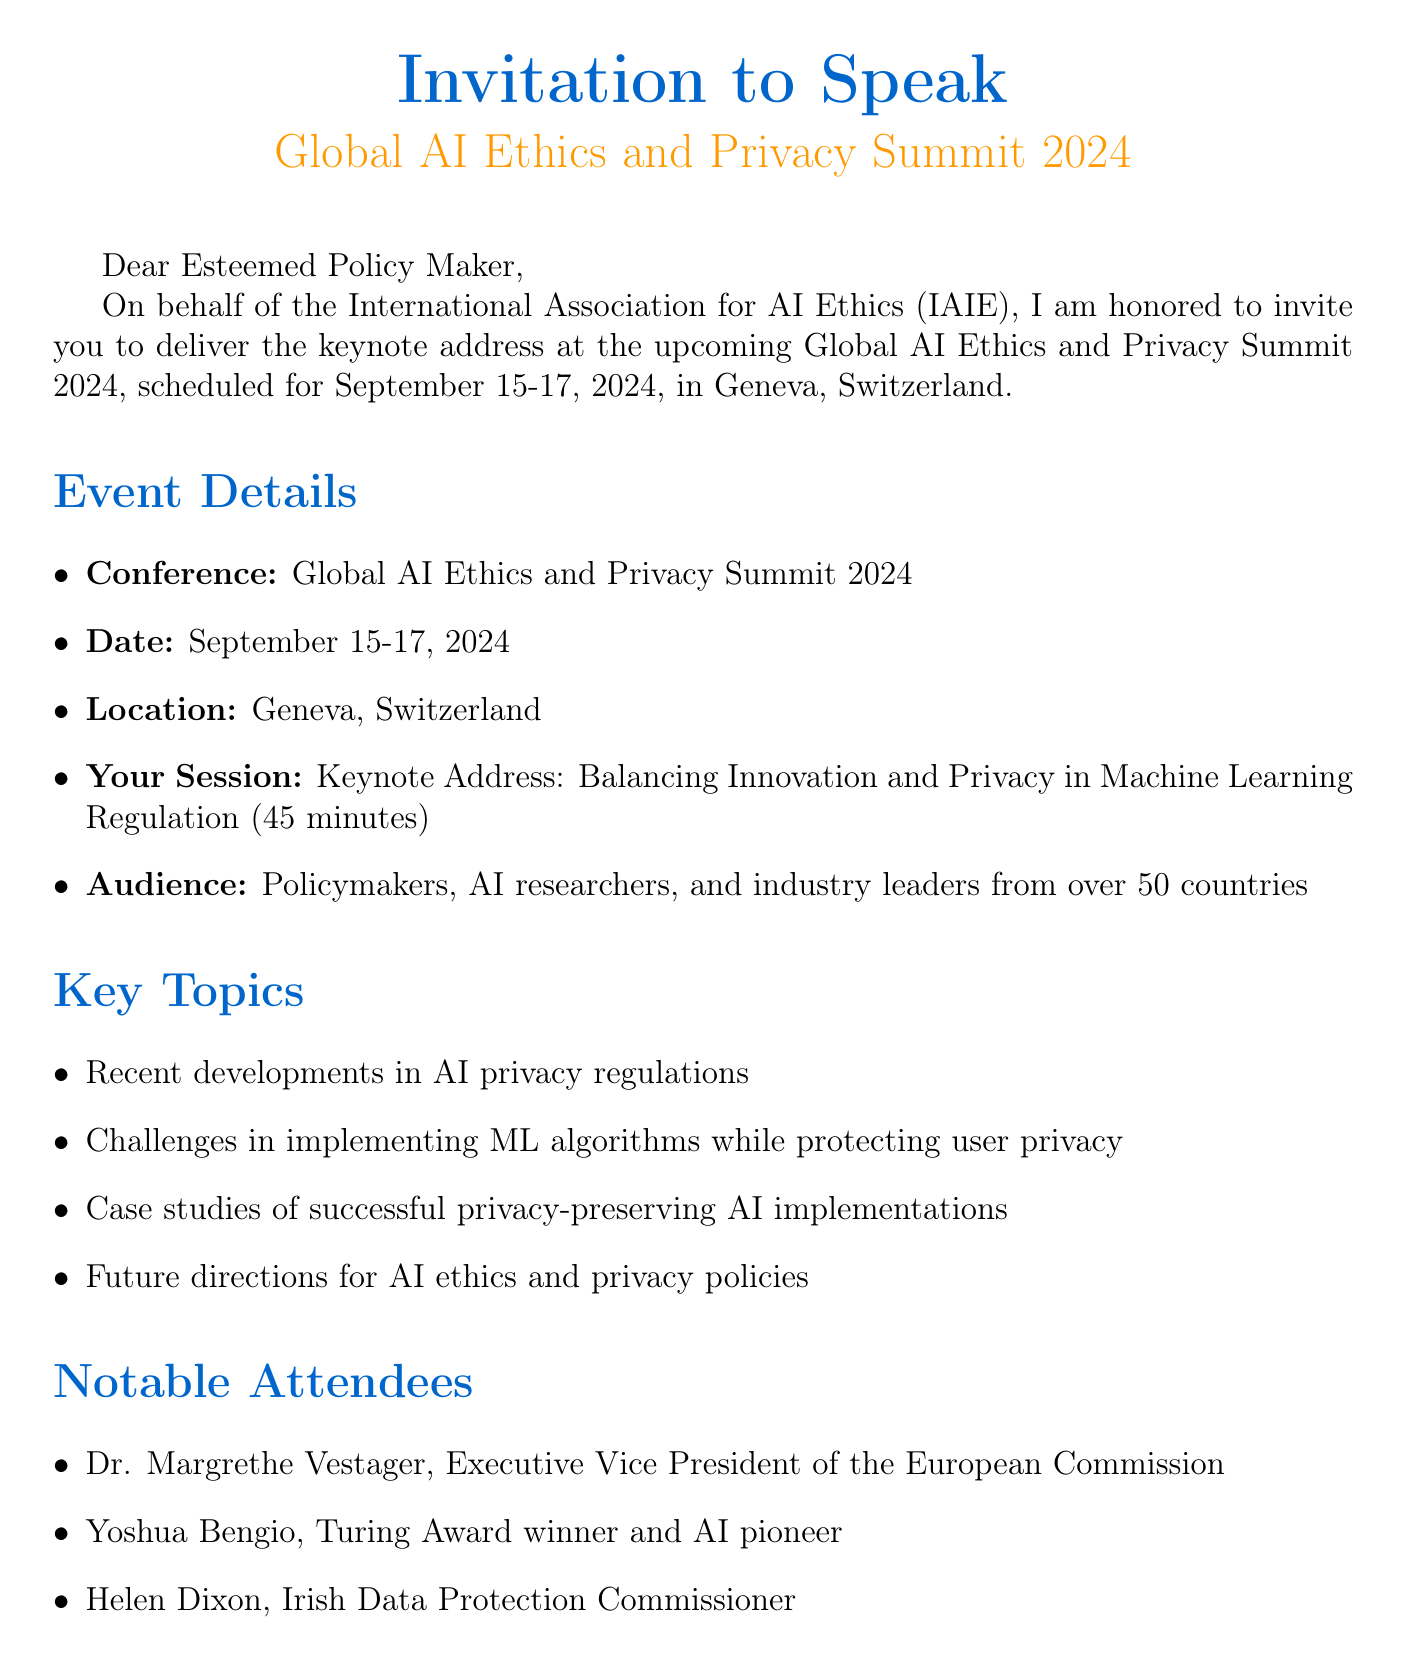what is the name of the conference? The name of the conference is explicitly mentioned in the document as the Global AI Ethics and Privacy Summit 2024.
Answer: Global AI Ethics and Privacy Summit 2024 what are the dates of the conference? The dates of the conference are provided in the document as September 15-17, 2024.
Answer: September 15-17, 2024 how long is the keynote address session? The duration of the keynote address session is described in the document as 45 minutes.
Answer: 45 minutes who is the contact person for the event? The contact person is identified in the document, including their title and role.
Answer: Dr. Sophia Chen what is the honorarium for the speaker? The honorarium for the speaker is clearly stated in the document as €2,000.
Answer: €2,000 which notable attendee is an AI pioneer? The document mentions one notable attendee recognized as an AI pioneer.
Answer: Yoshua Bengio what is required by May 31, 2024? The document specifies a response is required by that date.
Answer: Response Required By what is one of the key topics discussed at the conference? The document lists multiple key topics for discussion, focusing on AI and privacy.
Answer: Recent developments in AI privacy regulations how many countries will the audience come from? The audience is said to be from over 50 countries, which is specified in the document.
Answer: over 50 countries what type of session is the keynote address? The document describes this session as a keynote address, indicating its significance.
Answer: Keynote Address 